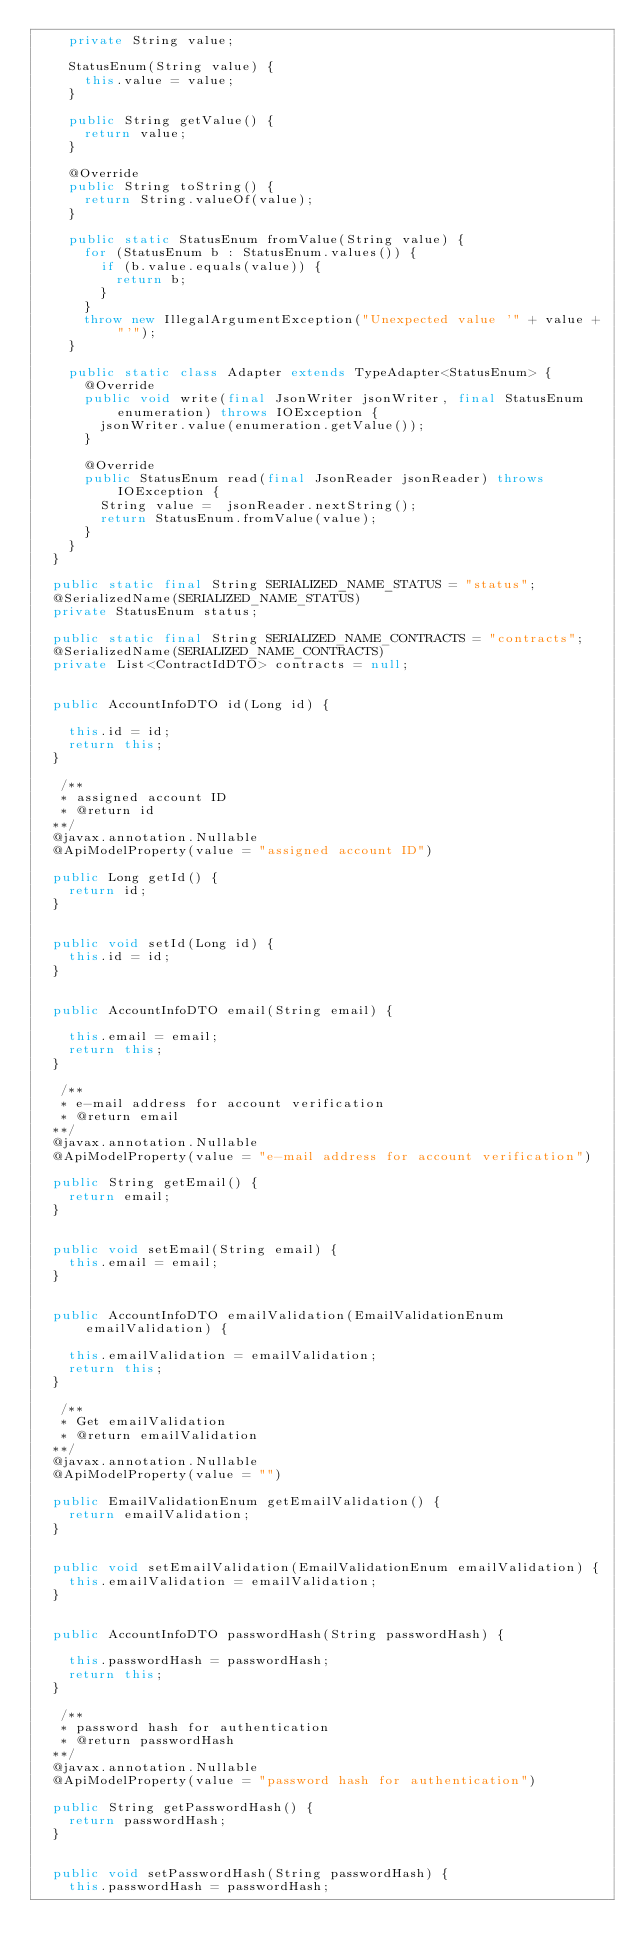Convert code to text. <code><loc_0><loc_0><loc_500><loc_500><_Java_>    private String value;

    StatusEnum(String value) {
      this.value = value;
    }

    public String getValue() {
      return value;
    }

    @Override
    public String toString() {
      return String.valueOf(value);
    }

    public static StatusEnum fromValue(String value) {
      for (StatusEnum b : StatusEnum.values()) {
        if (b.value.equals(value)) {
          return b;
        }
      }
      throw new IllegalArgumentException("Unexpected value '" + value + "'");
    }

    public static class Adapter extends TypeAdapter<StatusEnum> {
      @Override
      public void write(final JsonWriter jsonWriter, final StatusEnum enumeration) throws IOException {
        jsonWriter.value(enumeration.getValue());
      }

      @Override
      public StatusEnum read(final JsonReader jsonReader) throws IOException {
        String value =  jsonReader.nextString();
        return StatusEnum.fromValue(value);
      }
    }
  }

  public static final String SERIALIZED_NAME_STATUS = "status";
  @SerializedName(SERIALIZED_NAME_STATUS)
  private StatusEnum status;

  public static final String SERIALIZED_NAME_CONTRACTS = "contracts";
  @SerializedName(SERIALIZED_NAME_CONTRACTS)
  private List<ContractIdDTO> contracts = null;


  public AccountInfoDTO id(Long id) {
    
    this.id = id;
    return this;
  }

   /**
   * assigned account ID
   * @return id
  **/
  @javax.annotation.Nullable
  @ApiModelProperty(value = "assigned account ID")

  public Long getId() {
    return id;
  }


  public void setId(Long id) {
    this.id = id;
  }


  public AccountInfoDTO email(String email) {
    
    this.email = email;
    return this;
  }

   /**
   * e-mail address for account verification
   * @return email
  **/
  @javax.annotation.Nullable
  @ApiModelProperty(value = "e-mail address for account verification")

  public String getEmail() {
    return email;
  }


  public void setEmail(String email) {
    this.email = email;
  }


  public AccountInfoDTO emailValidation(EmailValidationEnum emailValidation) {
    
    this.emailValidation = emailValidation;
    return this;
  }

   /**
   * Get emailValidation
   * @return emailValidation
  **/
  @javax.annotation.Nullable
  @ApiModelProperty(value = "")

  public EmailValidationEnum getEmailValidation() {
    return emailValidation;
  }


  public void setEmailValidation(EmailValidationEnum emailValidation) {
    this.emailValidation = emailValidation;
  }


  public AccountInfoDTO passwordHash(String passwordHash) {
    
    this.passwordHash = passwordHash;
    return this;
  }

   /**
   * password hash for authentication
   * @return passwordHash
  **/
  @javax.annotation.Nullable
  @ApiModelProperty(value = "password hash for authentication")

  public String getPasswordHash() {
    return passwordHash;
  }


  public void setPasswordHash(String passwordHash) {
    this.passwordHash = passwordHash;</code> 